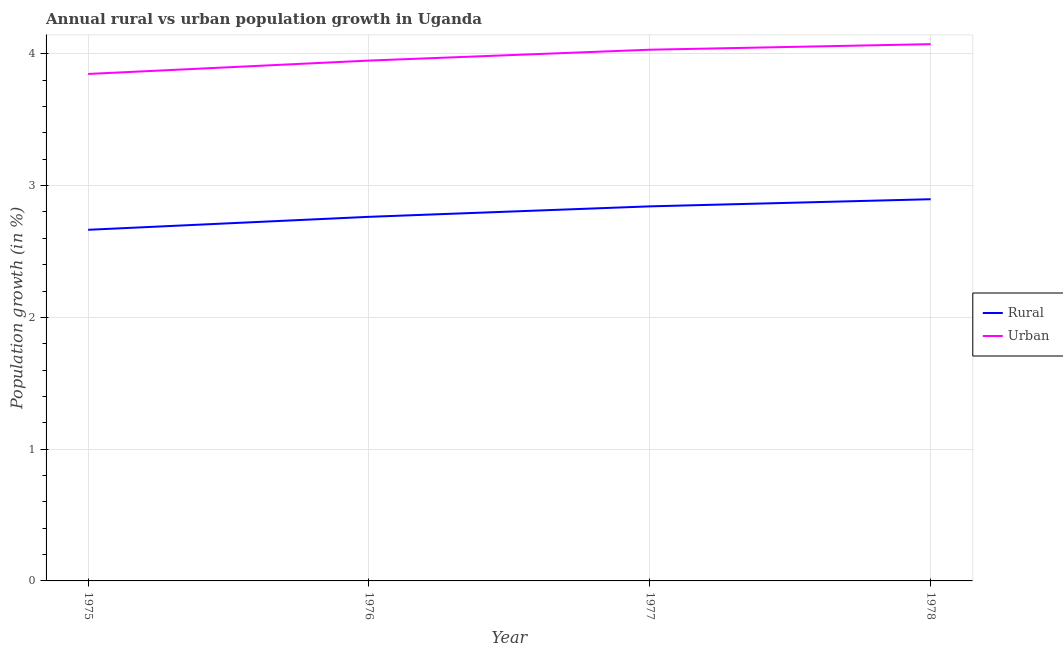Is the number of lines equal to the number of legend labels?
Give a very brief answer. Yes. What is the rural population growth in 1975?
Your answer should be very brief. 2.66. Across all years, what is the maximum rural population growth?
Your answer should be very brief. 2.9. Across all years, what is the minimum urban population growth?
Provide a short and direct response. 3.85. In which year was the rural population growth maximum?
Ensure brevity in your answer.  1978. In which year was the urban population growth minimum?
Your response must be concise. 1975. What is the total urban population growth in the graph?
Ensure brevity in your answer.  15.9. What is the difference between the urban population growth in 1976 and that in 1978?
Ensure brevity in your answer.  -0.12. What is the difference between the rural population growth in 1975 and the urban population growth in 1976?
Ensure brevity in your answer.  -1.28. What is the average urban population growth per year?
Provide a succinct answer. 3.98. In the year 1978, what is the difference between the urban population growth and rural population growth?
Ensure brevity in your answer.  1.18. What is the ratio of the rural population growth in 1975 to that in 1978?
Provide a short and direct response. 0.92. Is the difference between the urban population growth in 1975 and 1978 greater than the difference between the rural population growth in 1975 and 1978?
Your response must be concise. Yes. What is the difference between the highest and the second highest urban population growth?
Give a very brief answer. 0.04. What is the difference between the highest and the lowest rural population growth?
Make the answer very short. 0.23. In how many years, is the urban population growth greater than the average urban population growth taken over all years?
Offer a very short reply. 2. Does the rural population growth monotonically increase over the years?
Your answer should be compact. Yes. Is the rural population growth strictly less than the urban population growth over the years?
Offer a terse response. Yes. How many years are there in the graph?
Offer a terse response. 4. What is the difference between two consecutive major ticks on the Y-axis?
Give a very brief answer. 1. Does the graph contain any zero values?
Keep it short and to the point. No. Does the graph contain grids?
Make the answer very short. Yes. Where does the legend appear in the graph?
Ensure brevity in your answer.  Center right. What is the title of the graph?
Your answer should be compact. Annual rural vs urban population growth in Uganda. Does "From World Bank" appear as one of the legend labels in the graph?
Offer a very short reply. No. What is the label or title of the Y-axis?
Your response must be concise. Population growth (in %). What is the Population growth (in %) in Rural in 1975?
Provide a short and direct response. 2.66. What is the Population growth (in %) of Urban  in 1975?
Give a very brief answer. 3.85. What is the Population growth (in %) of Rural in 1976?
Give a very brief answer. 2.76. What is the Population growth (in %) in Urban  in 1976?
Provide a short and direct response. 3.95. What is the Population growth (in %) of Rural in 1977?
Ensure brevity in your answer.  2.84. What is the Population growth (in %) in Urban  in 1977?
Provide a succinct answer. 4.03. What is the Population growth (in %) in Rural in 1978?
Provide a succinct answer. 2.9. What is the Population growth (in %) of Urban  in 1978?
Give a very brief answer. 4.07. Across all years, what is the maximum Population growth (in %) of Rural?
Your answer should be compact. 2.9. Across all years, what is the maximum Population growth (in %) of Urban ?
Provide a short and direct response. 4.07. Across all years, what is the minimum Population growth (in %) in Rural?
Make the answer very short. 2.66. Across all years, what is the minimum Population growth (in %) of Urban ?
Provide a short and direct response. 3.85. What is the total Population growth (in %) of Rural in the graph?
Ensure brevity in your answer.  11.17. What is the total Population growth (in %) in Urban  in the graph?
Your response must be concise. 15.9. What is the difference between the Population growth (in %) of Rural in 1975 and that in 1976?
Make the answer very short. -0.1. What is the difference between the Population growth (in %) in Urban  in 1975 and that in 1976?
Offer a terse response. -0.1. What is the difference between the Population growth (in %) in Rural in 1975 and that in 1977?
Your answer should be very brief. -0.18. What is the difference between the Population growth (in %) of Urban  in 1975 and that in 1977?
Offer a terse response. -0.18. What is the difference between the Population growth (in %) in Rural in 1975 and that in 1978?
Make the answer very short. -0.23. What is the difference between the Population growth (in %) in Urban  in 1975 and that in 1978?
Your answer should be compact. -0.23. What is the difference between the Population growth (in %) in Rural in 1976 and that in 1977?
Give a very brief answer. -0.08. What is the difference between the Population growth (in %) in Urban  in 1976 and that in 1977?
Make the answer very short. -0.08. What is the difference between the Population growth (in %) in Rural in 1976 and that in 1978?
Provide a succinct answer. -0.13. What is the difference between the Population growth (in %) in Urban  in 1976 and that in 1978?
Offer a terse response. -0.12. What is the difference between the Population growth (in %) of Rural in 1977 and that in 1978?
Keep it short and to the point. -0.05. What is the difference between the Population growth (in %) of Urban  in 1977 and that in 1978?
Keep it short and to the point. -0.04. What is the difference between the Population growth (in %) in Rural in 1975 and the Population growth (in %) in Urban  in 1976?
Ensure brevity in your answer.  -1.28. What is the difference between the Population growth (in %) in Rural in 1975 and the Population growth (in %) in Urban  in 1977?
Your answer should be compact. -1.37. What is the difference between the Population growth (in %) in Rural in 1975 and the Population growth (in %) in Urban  in 1978?
Offer a very short reply. -1.41. What is the difference between the Population growth (in %) in Rural in 1976 and the Population growth (in %) in Urban  in 1977?
Your answer should be very brief. -1.27. What is the difference between the Population growth (in %) in Rural in 1976 and the Population growth (in %) in Urban  in 1978?
Provide a succinct answer. -1.31. What is the difference between the Population growth (in %) in Rural in 1977 and the Population growth (in %) in Urban  in 1978?
Provide a succinct answer. -1.23. What is the average Population growth (in %) in Rural per year?
Provide a short and direct response. 2.79. What is the average Population growth (in %) in Urban  per year?
Make the answer very short. 3.98. In the year 1975, what is the difference between the Population growth (in %) in Rural and Population growth (in %) in Urban ?
Offer a very short reply. -1.18. In the year 1976, what is the difference between the Population growth (in %) of Rural and Population growth (in %) of Urban ?
Give a very brief answer. -1.19. In the year 1977, what is the difference between the Population growth (in %) of Rural and Population growth (in %) of Urban ?
Provide a succinct answer. -1.19. In the year 1978, what is the difference between the Population growth (in %) of Rural and Population growth (in %) of Urban ?
Give a very brief answer. -1.18. What is the ratio of the Population growth (in %) of Rural in 1975 to that in 1976?
Offer a terse response. 0.96. What is the ratio of the Population growth (in %) in Urban  in 1975 to that in 1976?
Your answer should be very brief. 0.97. What is the ratio of the Population growth (in %) of Urban  in 1975 to that in 1977?
Make the answer very short. 0.95. What is the ratio of the Population growth (in %) of Rural in 1975 to that in 1978?
Your response must be concise. 0.92. What is the ratio of the Population growth (in %) of Urban  in 1975 to that in 1978?
Ensure brevity in your answer.  0.94. What is the ratio of the Population growth (in %) in Rural in 1976 to that in 1977?
Ensure brevity in your answer.  0.97. What is the ratio of the Population growth (in %) in Urban  in 1976 to that in 1977?
Make the answer very short. 0.98. What is the ratio of the Population growth (in %) in Rural in 1976 to that in 1978?
Your response must be concise. 0.95. What is the ratio of the Population growth (in %) in Urban  in 1976 to that in 1978?
Provide a short and direct response. 0.97. What is the ratio of the Population growth (in %) of Rural in 1977 to that in 1978?
Your response must be concise. 0.98. What is the difference between the highest and the second highest Population growth (in %) in Rural?
Offer a very short reply. 0.05. What is the difference between the highest and the second highest Population growth (in %) of Urban ?
Offer a very short reply. 0.04. What is the difference between the highest and the lowest Population growth (in %) of Rural?
Your response must be concise. 0.23. What is the difference between the highest and the lowest Population growth (in %) of Urban ?
Offer a terse response. 0.23. 